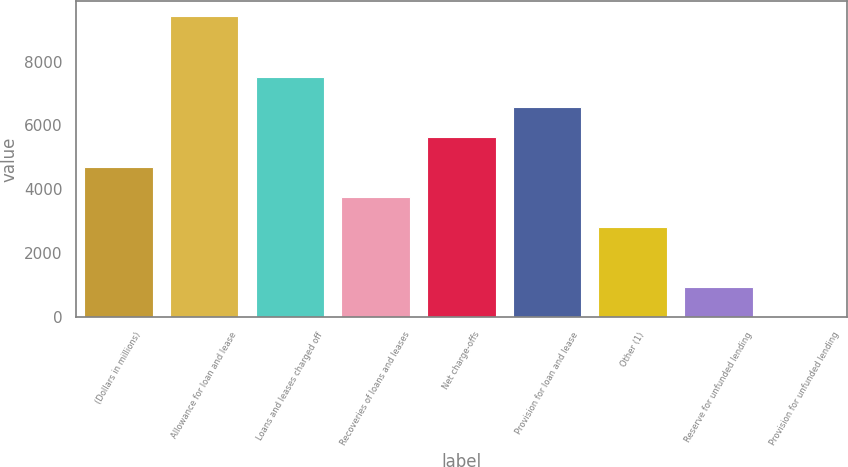Convert chart. <chart><loc_0><loc_0><loc_500><loc_500><bar_chart><fcel>(Dollars in millions)<fcel>Allowance for loan and lease<fcel>Loans and leases charged off<fcel>Recoveries of loans and leases<fcel>Net charge-offs<fcel>Provision for loan and lease<fcel>Other (1)<fcel>Reserve for unfunded lending<fcel>Provision for unfunded lending<nl><fcel>4711<fcel>9413<fcel>7532.2<fcel>3770.6<fcel>5651.4<fcel>6591.8<fcel>2830.2<fcel>949.4<fcel>9<nl></chart> 